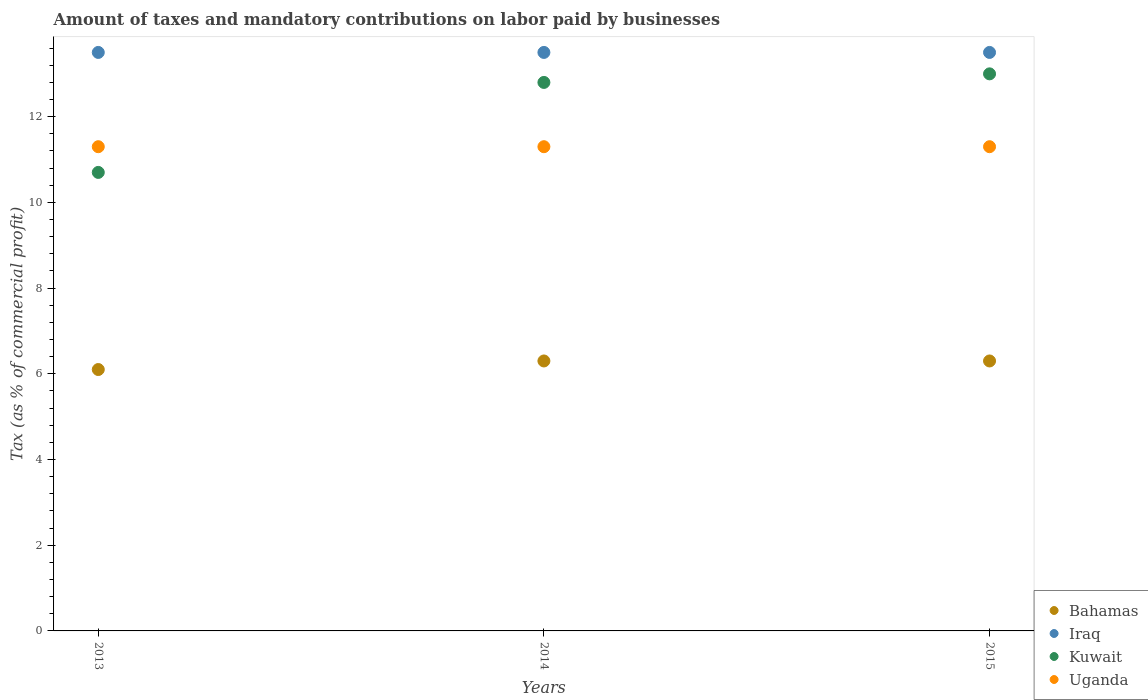Is the number of dotlines equal to the number of legend labels?
Offer a very short reply. Yes. What is the percentage of taxes paid by businesses in Kuwait in 2013?
Ensure brevity in your answer.  10.7. In which year was the percentage of taxes paid by businesses in Kuwait maximum?
Ensure brevity in your answer.  2015. What is the total percentage of taxes paid by businesses in Iraq in the graph?
Your response must be concise. 40.5. What is the difference between the percentage of taxes paid by businesses in Uganda in 2013 and the percentage of taxes paid by businesses in Iraq in 2014?
Provide a succinct answer. -2.2. What is the average percentage of taxes paid by businesses in Kuwait per year?
Make the answer very short. 12.17. In how many years, is the percentage of taxes paid by businesses in Iraq greater than 13.2 %?
Keep it short and to the point. 3. What is the difference between the highest and the lowest percentage of taxes paid by businesses in Kuwait?
Offer a very short reply. 2.3. Is it the case that in every year, the sum of the percentage of taxes paid by businesses in Kuwait and percentage of taxes paid by businesses in Uganda  is greater than the sum of percentage of taxes paid by businesses in Iraq and percentage of taxes paid by businesses in Bahamas?
Offer a terse response. No. Is it the case that in every year, the sum of the percentage of taxes paid by businesses in Kuwait and percentage of taxes paid by businesses in Iraq  is greater than the percentage of taxes paid by businesses in Uganda?
Offer a terse response. Yes. Is the percentage of taxes paid by businesses in Bahamas strictly less than the percentage of taxes paid by businesses in Iraq over the years?
Your answer should be very brief. Yes. How many dotlines are there?
Keep it short and to the point. 4. What is the difference between two consecutive major ticks on the Y-axis?
Offer a very short reply. 2. Does the graph contain grids?
Offer a terse response. No. Where does the legend appear in the graph?
Your answer should be very brief. Bottom right. How many legend labels are there?
Offer a terse response. 4. What is the title of the graph?
Provide a succinct answer. Amount of taxes and mandatory contributions on labor paid by businesses. Does "Puerto Rico" appear as one of the legend labels in the graph?
Your response must be concise. No. What is the label or title of the Y-axis?
Your answer should be compact. Tax (as % of commercial profit). What is the Tax (as % of commercial profit) in Kuwait in 2013?
Your answer should be very brief. 10.7. What is the Tax (as % of commercial profit) of Uganda in 2014?
Make the answer very short. 11.3. What is the Tax (as % of commercial profit) of Kuwait in 2015?
Ensure brevity in your answer.  13. Across all years, what is the maximum Tax (as % of commercial profit) of Bahamas?
Offer a terse response. 6.3. Across all years, what is the maximum Tax (as % of commercial profit) of Kuwait?
Ensure brevity in your answer.  13. Across all years, what is the maximum Tax (as % of commercial profit) in Uganda?
Offer a terse response. 11.3. Across all years, what is the minimum Tax (as % of commercial profit) in Bahamas?
Keep it short and to the point. 6.1. Across all years, what is the minimum Tax (as % of commercial profit) of Iraq?
Give a very brief answer. 13.5. Across all years, what is the minimum Tax (as % of commercial profit) of Uganda?
Offer a very short reply. 11.3. What is the total Tax (as % of commercial profit) of Iraq in the graph?
Your response must be concise. 40.5. What is the total Tax (as % of commercial profit) in Kuwait in the graph?
Your answer should be compact. 36.5. What is the total Tax (as % of commercial profit) of Uganda in the graph?
Your answer should be compact. 33.9. What is the difference between the Tax (as % of commercial profit) in Bahamas in 2013 and that in 2014?
Your answer should be very brief. -0.2. What is the difference between the Tax (as % of commercial profit) of Uganda in 2013 and that in 2015?
Offer a very short reply. 0. What is the difference between the Tax (as % of commercial profit) of Iraq in 2013 and the Tax (as % of commercial profit) of Uganda in 2014?
Your response must be concise. 2.2. What is the difference between the Tax (as % of commercial profit) of Kuwait in 2013 and the Tax (as % of commercial profit) of Uganda in 2014?
Your response must be concise. -0.6. What is the difference between the Tax (as % of commercial profit) of Bahamas in 2013 and the Tax (as % of commercial profit) of Iraq in 2015?
Provide a short and direct response. -7.4. What is the difference between the Tax (as % of commercial profit) in Bahamas in 2013 and the Tax (as % of commercial profit) in Kuwait in 2015?
Your answer should be very brief. -6.9. What is the difference between the Tax (as % of commercial profit) of Bahamas in 2013 and the Tax (as % of commercial profit) of Uganda in 2015?
Make the answer very short. -5.2. What is the difference between the Tax (as % of commercial profit) of Bahamas in 2014 and the Tax (as % of commercial profit) of Kuwait in 2015?
Keep it short and to the point. -6.7. What is the difference between the Tax (as % of commercial profit) of Bahamas in 2014 and the Tax (as % of commercial profit) of Uganda in 2015?
Provide a short and direct response. -5. What is the difference between the Tax (as % of commercial profit) of Kuwait in 2014 and the Tax (as % of commercial profit) of Uganda in 2015?
Ensure brevity in your answer.  1.5. What is the average Tax (as % of commercial profit) in Bahamas per year?
Give a very brief answer. 6.23. What is the average Tax (as % of commercial profit) of Iraq per year?
Provide a short and direct response. 13.5. What is the average Tax (as % of commercial profit) of Kuwait per year?
Keep it short and to the point. 12.17. In the year 2013, what is the difference between the Tax (as % of commercial profit) of Bahamas and Tax (as % of commercial profit) of Iraq?
Offer a terse response. -7.4. In the year 2013, what is the difference between the Tax (as % of commercial profit) in Bahamas and Tax (as % of commercial profit) in Kuwait?
Provide a succinct answer. -4.6. In the year 2013, what is the difference between the Tax (as % of commercial profit) in Iraq and Tax (as % of commercial profit) in Kuwait?
Provide a succinct answer. 2.8. In the year 2013, what is the difference between the Tax (as % of commercial profit) of Iraq and Tax (as % of commercial profit) of Uganda?
Your answer should be compact. 2.2. In the year 2014, what is the difference between the Tax (as % of commercial profit) in Bahamas and Tax (as % of commercial profit) in Uganda?
Give a very brief answer. -5. In the year 2014, what is the difference between the Tax (as % of commercial profit) of Iraq and Tax (as % of commercial profit) of Kuwait?
Your response must be concise. 0.7. In the year 2014, what is the difference between the Tax (as % of commercial profit) in Kuwait and Tax (as % of commercial profit) in Uganda?
Provide a succinct answer. 1.5. In the year 2015, what is the difference between the Tax (as % of commercial profit) of Bahamas and Tax (as % of commercial profit) of Iraq?
Offer a very short reply. -7.2. In the year 2015, what is the difference between the Tax (as % of commercial profit) of Bahamas and Tax (as % of commercial profit) of Kuwait?
Offer a terse response. -6.7. In the year 2015, what is the difference between the Tax (as % of commercial profit) in Bahamas and Tax (as % of commercial profit) in Uganda?
Your answer should be very brief. -5. In the year 2015, what is the difference between the Tax (as % of commercial profit) in Iraq and Tax (as % of commercial profit) in Kuwait?
Give a very brief answer. 0.5. What is the ratio of the Tax (as % of commercial profit) of Bahamas in 2013 to that in 2014?
Offer a very short reply. 0.97. What is the ratio of the Tax (as % of commercial profit) in Kuwait in 2013 to that in 2014?
Give a very brief answer. 0.84. What is the ratio of the Tax (as % of commercial profit) in Uganda in 2013 to that in 2014?
Offer a very short reply. 1. What is the ratio of the Tax (as % of commercial profit) of Bahamas in 2013 to that in 2015?
Offer a terse response. 0.97. What is the ratio of the Tax (as % of commercial profit) in Kuwait in 2013 to that in 2015?
Offer a terse response. 0.82. What is the ratio of the Tax (as % of commercial profit) in Bahamas in 2014 to that in 2015?
Give a very brief answer. 1. What is the ratio of the Tax (as % of commercial profit) in Kuwait in 2014 to that in 2015?
Your answer should be compact. 0.98. What is the ratio of the Tax (as % of commercial profit) in Uganda in 2014 to that in 2015?
Your answer should be compact. 1. What is the difference between the highest and the second highest Tax (as % of commercial profit) in Bahamas?
Your response must be concise. 0. What is the difference between the highest and the second highest Tax (as % of commercial profit) of Kuwait?
Provide a short and direct response. 0.2. What is the difference between the highest and the lowest Tax (as % of commercial profit) of Uganda?
Ensure brevity in your answer.  0. 